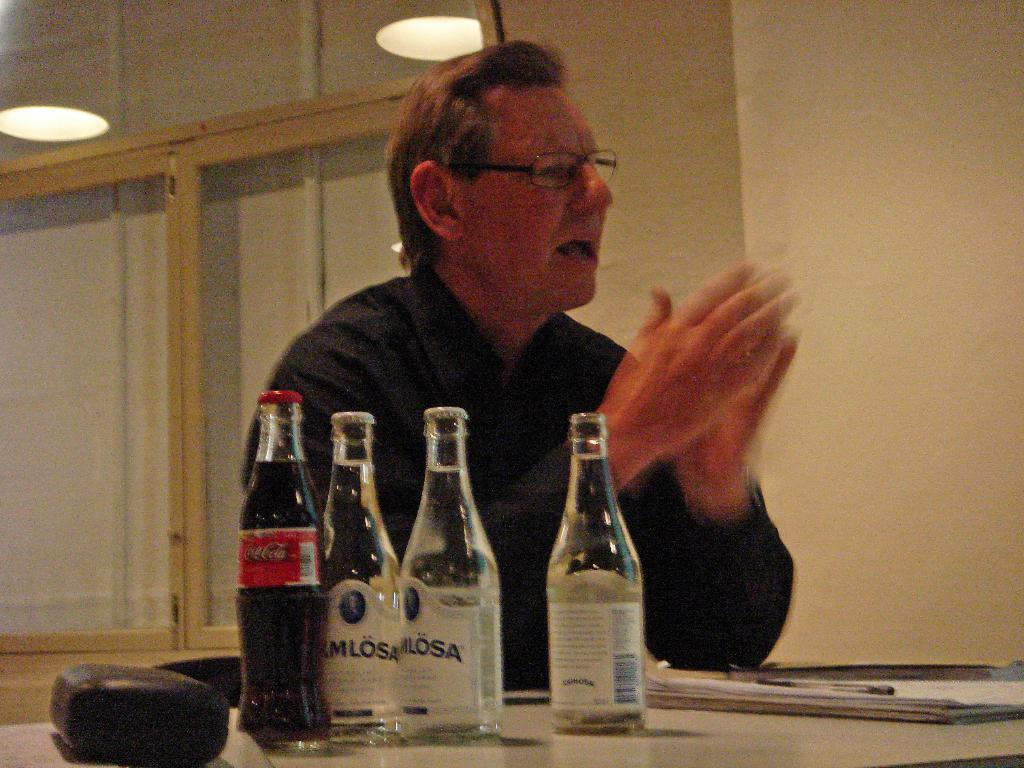<image>
Give a short and clear explanation of the subsequent image. A man wearing glasses is sitting next to a coke bottle and three clear bottles of liquid. 